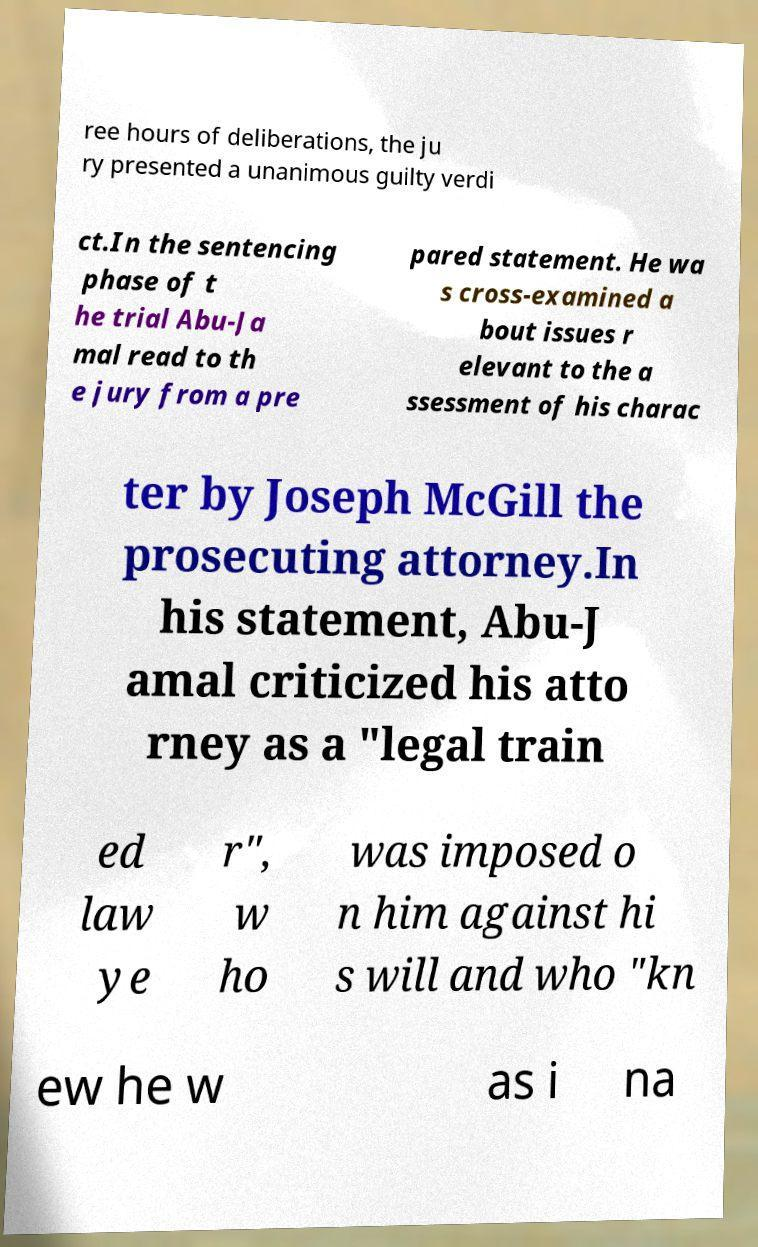For documentation purposes, I need the text within this image transcribed. Could you provide that? ree hours of deliberations, the ju ry presented a unanimous guilty verdi ct.In the sentencing phase of t he trial Abu-Ja mal read to th e jury from a pre pared statement. He wa s cross-examined a bout issues r elevant to the a ssessment of his charac ter by Joseph McGill the prosecuting attorney.In his statement, Abu-J amal criticized his atto rney as a "legal train ed law ye r", w ho was imposed o n him against hi s will and who "kn ew he w as i na 